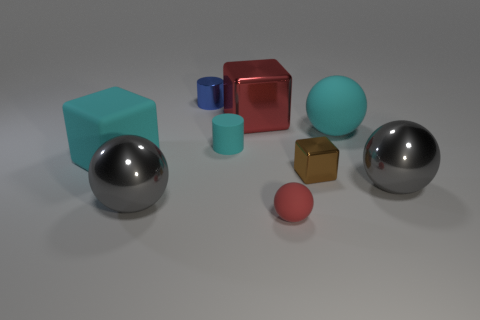Subtract all cyan spheres. How many spheres are left? 3 Subtract all tiny red spheres. How many spheres are left? 3 Subtract all brown spheres. Subtract all red blocks. How many spheres are left? 4 Add 1 cyan spheres. How many objects exist? 10 Subtract all cylinders. How many objects are left? 7 Add 7 big yellow matte cubes. How many big yellow matte cubes exist? 7 Subtract 1 gray balls. How many objects are left? 8 Subtract all large red metallic objects. Subtract all red spheres. How many objects are left? 7 Add 9 red matte spheres. How many red matte spheres are left? 10 